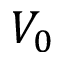<formula> <loc_0><loc_0><loc_500><loc_500>V _ { 0 }</formula> 